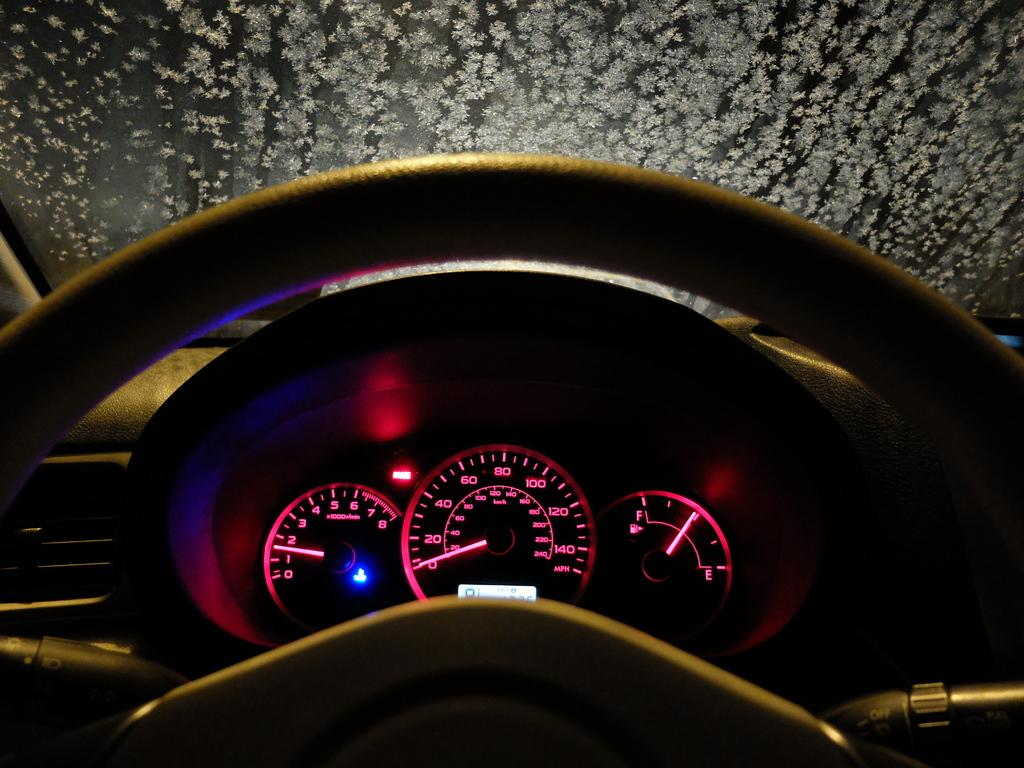Where was the image taken? The image was taken inside a car. What can be seen at the top of the image? There is a windshield at the top of the image. What is located in the middle of the image? A steering wheel and a meter are visible in the middle of the image. What type of shop can be seen in the image? There is no shop present in the image; it is taken inside a car. Can you touch the meter in the image? The image is a photograph, so you cannot physically touch the meter in the image. 